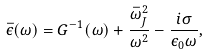Convert formula to latex. <formula><loc_0><loc_0><loc_500><loc_500>\bar { \epsilon } ( \omega ) = G ^ { - 1 } ( \omega ) + \frac { \bar { \omega } _ { J } ^ { 2 } } { \omega ^ { 2 } } - \frac { i \sigma } { \epsilon _ { 0 } \omega } ,</formula> 